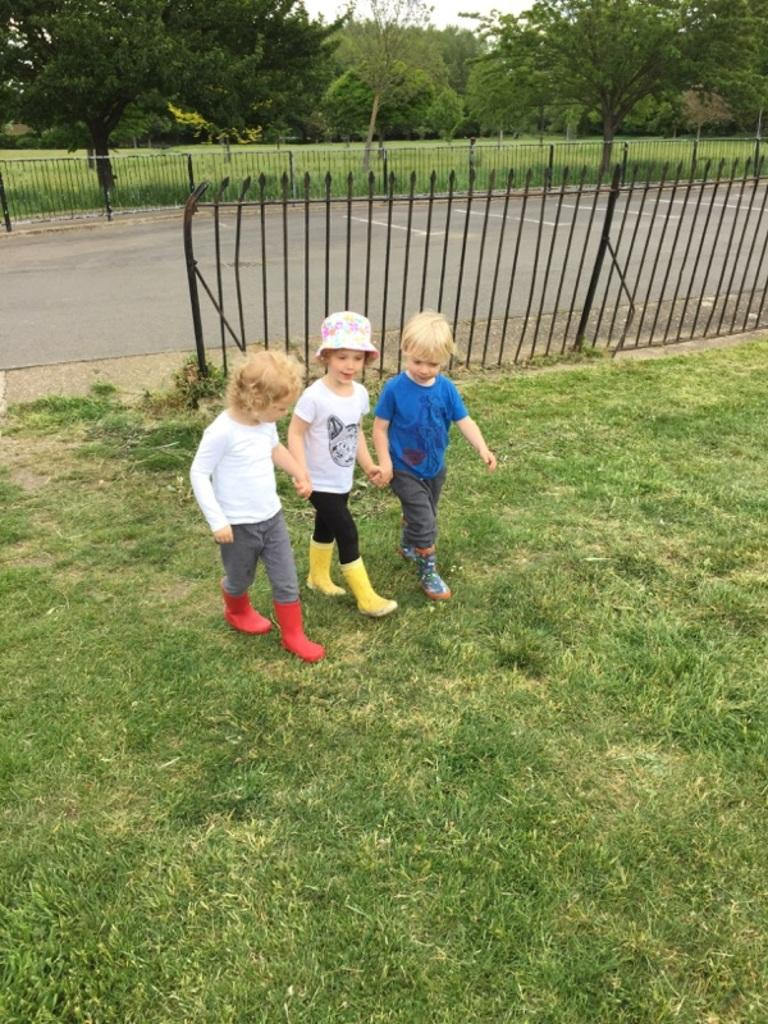How many boys are in the image? There are three boys in the foreground of the image. What are the boys doing in the image? The boys are walking on the grass. What can be seen in the background of the image? There is railing, a road, trees, and the sky visible in the background of the image. What type of sweater is the governor wearing in the image? There is no governor or sweater present in the image. What question is the boys discussing in the image? There is no indication of a discussion or a specific question in the image. 